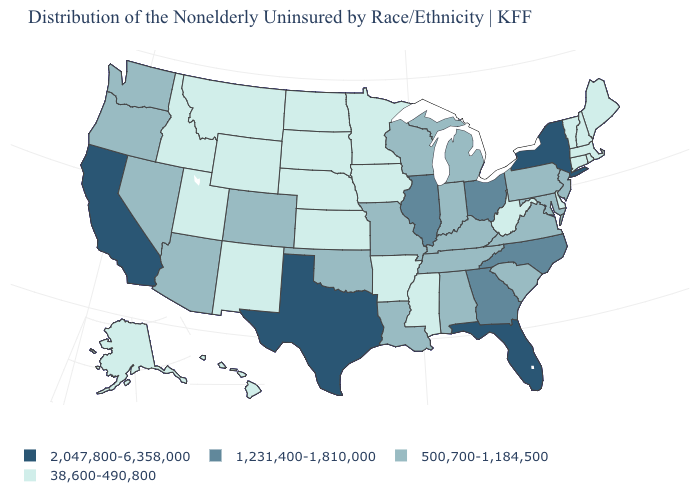Does Florida have the highest value in the USA?
Write a very short answer. Yes. What is the value of Rhode Island?
Keep it brief. 38,600-490,800. Does South Dakota have the same value as Connecticut?
Concise answer only. Yes. Is the legend a continuous bar?
Short answer required. No. Which states have the lowest value in the Northeast?
Keep it brief. Connecticut, Maine, Massachusetts, New Hampshire, Rhode Island, Vermont. Name the states that have a value in the range 38,600-490,800?
Quick response, please. Alaska, Arkansas, Connecticut, Delaware, Hawaii, Idaho, Iowa, Kansas, Maine, Massachusetts, Minnesota, Mississippi, Montana, Nebraska, New Hampshire, New Mexico, North Dakota, Rhode Island, South Dakota, Utah, Vermont, West Virginia, Wyoming. What is the value of Arkansas?
Concise answer only. 38,600-490,800. Name the states that have a value in the range 500,700-1,184,500?
Concise answer only. Alabama, Arizona, Colorado, Indiana, Kentucky, Louisiana, Maryland, Michigan, Missouri, Nevada, New Jersey, Oklahoma, Oregon, Pennsylvania, South Carolina, Tennessee, Virginia, Washington, Wisconsin. What is the highest value in states that border Indiana?
Quick response, please. 1,231,400-1,810,000. Among the states that border Wisconsin , does Iowa have the highest value?
Answer briefly. No. What is the lowest value in the USA?
Answer briefly. 38,600-490,800. Does New York have the lowest value in the Northeast?
Quick response, please. No. Which states hav the highest value in the West?
Give a very brief answer. California. Name the states that have a value in the range 500,700-1,184,500?
Keep it brief. Alabama, Arizona, Colorado, Indiana, Kentucky, Louisiana, Maryland, Michigan, Missouri, Nevada, New Jersey, Oklahoma, Oregon, Pennsylvania, South Carolina, Tennessee, Virginia, Washington, Wisconsin. Name the states that have a value in the range 2,047,800-6,358,000?
Give a very brief answer. California, Florida, New York, Texas. 